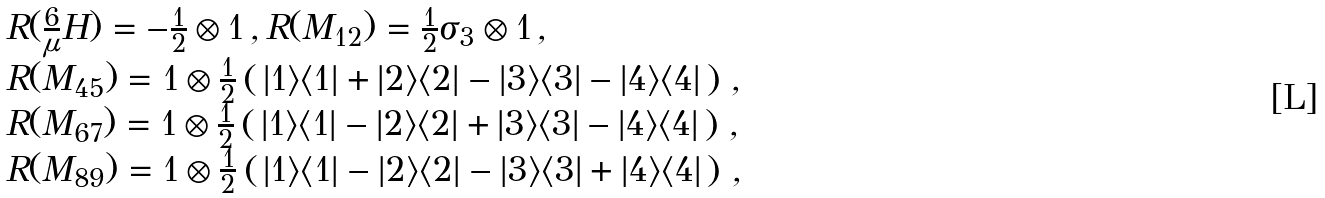<formula> <loc_0><loc_0><loc_500><loc_500>\begin{array} { l } R ( \frac { 6 } { \mu } H ) = - \frac { 1 } { 2 } \otimes 1 \, , R ( M _ { 1 2 } ) = \frac { 1 } { 2 } \sigma _ { 3 } \otimes 1 \, , \\ R ( M _ { 4 5 } ) = 1 \otimes \frac { 1 } { 2 } \left ( \, | 1 \rangle \langle 1 | + | 2 \rangle \langle 2 | - | 3 \rangle \langle 3 | - | 4 \rangle \langle 4 | \, \right ) \, , \\ R ( M _ { 6 7 } ) = 1 \otimes \frac { 1 } { 2 } \left ( \, | 1 \rangle \langle 1 | - | 2 \rangle \langle 2 | + | 3 \rangle \langle 3 | - | 4 \rangle \langle 4 | \, \right ) \, , \\ R ( M _ { 8 9 } ) = 1 \otimes \frac { 1 } { 2 } \left ( \, | 1 \rangle \langle 1 | - | 2 \rangle \langle 2 | - | 3 \rangle \langle 3 | + | 4 \rangle \langle 4 | \, \right ) \, , \end{array}</formula> 